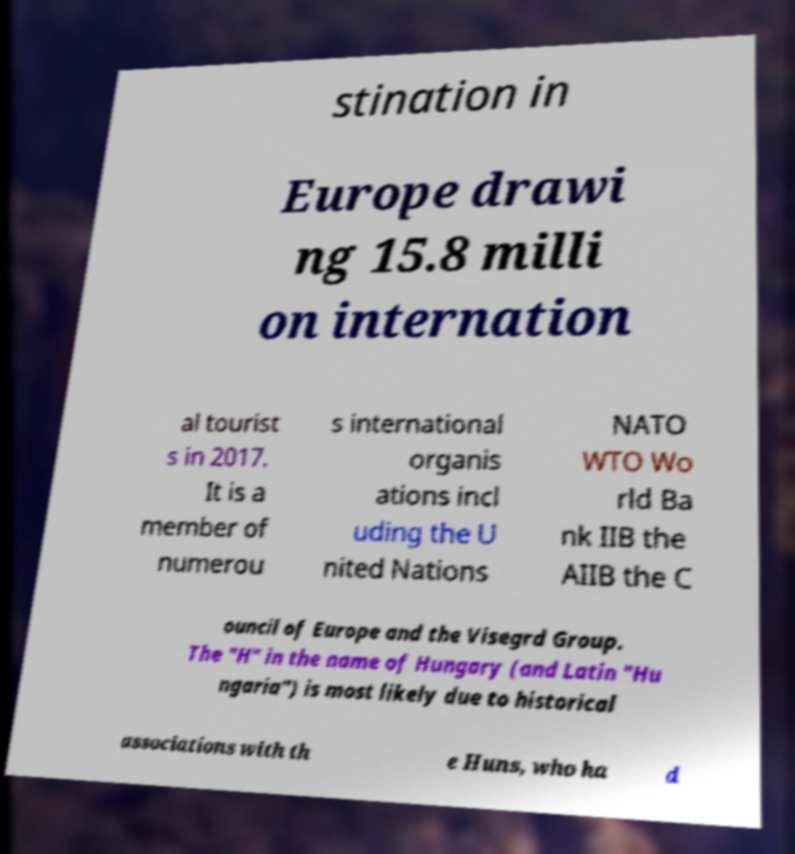Could you extract and type out the text from this image? stination in Europe drawi ng 15.8 milli on internation al tourist s in 2017. It is a member of numerou s international organis ations incl uding the U nited Nations NATO WTO Wo rld Ba nk IIB the AIIB the C ouncil of Europe and the Visegrd Group. The "H" in the name of Hungary (and Latin "Hu ngaria") is most likely due to historical associations with th e Huns, who ha d 